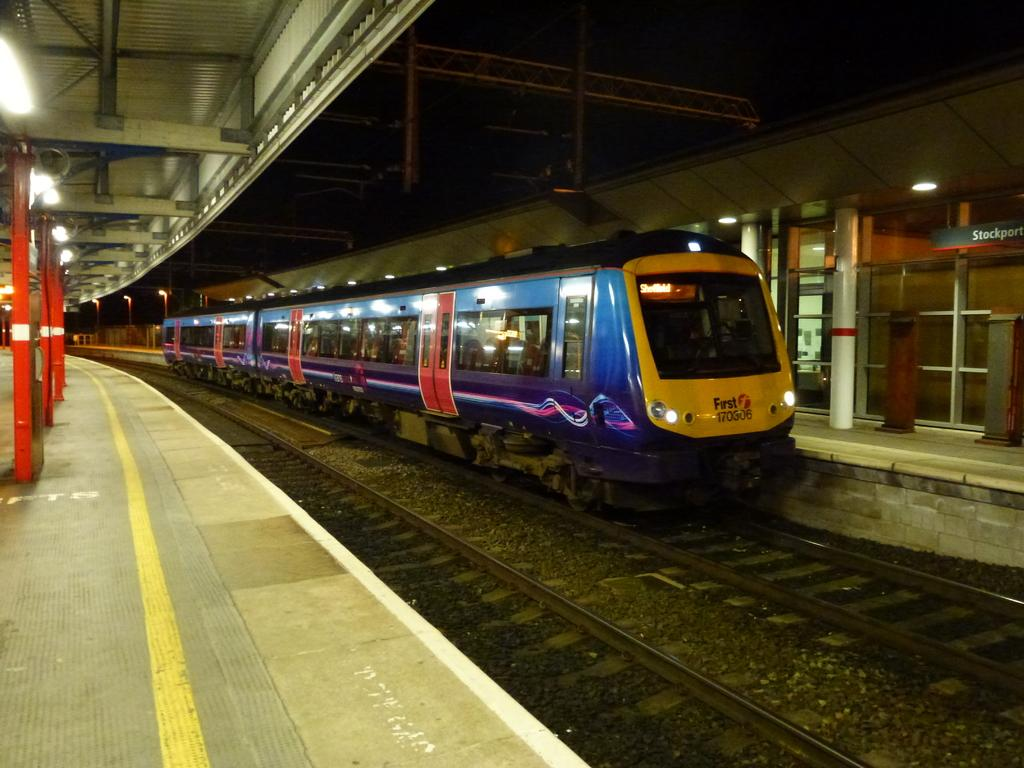What is the main subject of the image? The main subject of the image is a train. Where is the train located in the image? The train is on a track. Are there any people or objects near the train in the image? The platforms around the train are empty. How does the train maintain its balance on the tub in the image? There is no tub present in the image, and the train is on a track, not a tub. 